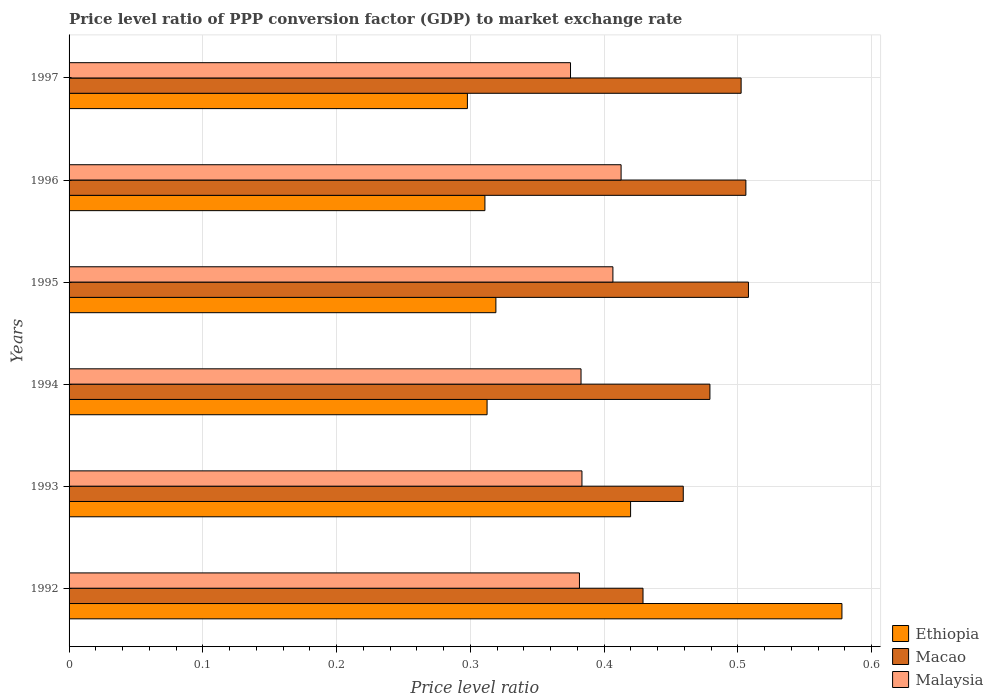How many groups of bars are there?
Your response must be concise. 6. Are the number of bars on each tick of the Y-axis equal?
Your response must be concise. Yes. How many bars are there on the 4th tick from the top?
Offer a very short reply. 3. In how many cases, is the number of bars for a given year not equal to the number of legend labels?
Give a very brief answer. 0. What is the price level ratio in Macao in 1997?
Ensure brevity in your answer.  0.5. Across all years, what is the maximum price level ratio in Macao?
Offer a terse response. 0.51. Across all years, what is the minimum price level ratio in Malaysia?
Provide a short and direct response. 0.37. In which year was the price level ratio in Ethiopia minimum?
Make the answer very short. 1997. What is the total price level ratio in Malaysia in the graph?
Provide a short and direct response. 2.34. What is the difference between the price level ratio in Macao in 1993 and that in 1996?
Provide a short and direct response. -0.05. What is the difference between the price level ratio in Ethiopia in 1992 and the price level ratio in Malaysia in 1997?
Give a very brief answer. 0.2. What is the average price level ratio in Malaysia per year?
Offer a very short reply. 0.39. In the year 1996, what is the difference between the price level ratio in Ethiopia and price level ratio in Malaysia?
Provide a short and direct response. -0.1. In how many years, is the price level ratio in Malaysia greater than 0.12000000000000001 ?
Give a very brief answer. 6. What is the ratio of the price level ratio in Ethiopia in 1996 to that in 1997?
Your answer should be compact. 1.04. Is the difference between the price level ratio in Ethiopia in 1995 and 1996 greater than the difference between the price level ratio in Malaysia in 1995 and 1996?
Your response must be concise. Yes. What is the difference between the highest and the second highest price level ratio in Malaysia?
Your response must be concise. 0.01. What is the difference between the highest and the lowest price level ratio in Macao?
Make the answer very short. 0.08. What does the 2nd bar from the top in 1995 represents?
Your answer should be very brief. Macao. What does the 3rd bar from the bottom in 1997 represents?
Your answer should be compact. Malaysia. Is it the case that in every year, the sum of the price level ratio in Malaysia and price level ratio in Macao is greater than the price level ratio in Ethiopia?
Make the answer very short. Yes. How many bars are there?
Make the answer very short. 18. How many years are there in the graph?
Offer a very short reply. 6. What is the difference between two consecutive major ticks on the X-axis?
Provide a succinct answer. 0.1. Are the values on the major ticks of X-axis written in scientific E-notation?
Keep it short and to the point. No. Does the graph contain any zero values?
Make the answer very short. No. Does the graph contain grids?
Provide a succinct answer. Yes. How are the legend labels stacked?
Your response must be concise. Vertical. What is the title of the graph?
Offer a very short reply. Price level ratio of PPP conversion factor (GDP) to market exchange rate. What is the label or title of the X-axis?
Your answer should be very brief. Price level ratio. What is the Price level ratio of Ethiopia in 1992?
Provide a short and direct response. 0.58. What is the Price level ratio in Macao in 1992?
Your answer should be very brief. 0.43. What is the Price level ratio of Malaysia in 1992?
Your response must be concise. 0.38. What is the Price level ratio in Ethiopia in 1993?
Keep it short and to the point. 0.42. What is the Price level ratio of Macao in 1993?
Ensure brevity in your answer.  0.46. What is the Price level ratio in Malaysia in 1993?
Your response must be concise. 0.38. What is the Price level ratio of Ethiopia in 1994?
Your answer should be compact. 0.31. What is the Price level ratio in Macao in 1994?
Provide a succinct answer. 0.48. What is the Price level ratio of Malaysia in 1994?
Your answer should be compact. 0.38. What is the Price level ratio of Ethiopia in 1995?
Offer a terse response. 0.32. What is the Price level ratio in Macao in 1995?
Provide a succinct answer. 0.51. What is the Price level ratio in Malaysia in 1995?
Your answer should be very brief. 0.41. What is the Price level ratio of Ethiopia in 1996?
Provide a short and direct response. 0.31. What is the Price level ratio of Macao in 1996?
Keep it short and to the point. 0.51. What is the Price level ratio of Malaysia in 1996?
Offer a very short reply. 0.41. What is the Price level ratio of Ethiopia in 1997?
Offer a terse response. 0.3. What is the Price level ratio in Macao in 1997?
Your answer should be very brief. 0.5. What is the Price level ratio of Malaysia in 1997?
Your answer should be very brief. 0.37. Across all years, what is the maximum Price level ratio in Ethiopia?
Make the answer very short. 0.58. Across all years, what is the maximum Price level ratio of Macao?
Ensure brevity in your answer.  0.51. Across all years, what is the maximum Price level ratio of Malaysia?
Your answer should be compact. 0.41. Across all years, what is the minimum Price level ratio in Ethiopia?
Make the answer very short. 0.3. Across all years, what is the minimum Price level ratio in Macao?
Make the answer very short. 0.43. Across all years, what is the minimum Price level ratio in Malaysia?
Provide a succinct answer. 0.37. What is the total Price level ratio of Ethiopia in the graph?
Provide a short and direct response. 2.24. What is the total Price level ratio in Macao in the graph?
Keep it short and to the point. 2.88. What is the total Price level ratio of Malaysia in the graph?
Your answer should be very brief. 2.34. What is the difference between the Price level ratio of Ethiopia in 1992 and that in 1993?
Make the answer very short. 0.16. What is the difference between the Price level ratio of Macao in 1992 and that in 1993?
Provide a succinct answer. -0.03. What is the difference between the Price level ratio of Malaysia in 1992 and that in 1993?
Offer a terse response. -0. What is the difference between the Price level ratio in Ethiopia in 1992 and that in 1994?
Offer a very short reply. 0.27. What is the difference between the Price level ratio of Malaysia in 1992 and that in 1994?
Make the answer very short. -0. What is the difference between the Price level ratio of Ethiopia in 1992 and that in 1995?
Keep it short and to the point. 0.26. What is the difference between the Price level ratio of Macao in 1992 and that in 1995?
Give a very brief answer. -0.08. What is the difference between the Price level ratio in Malaysia in 1992 and that in 1995?
Your response must be concise. -0.03. What is the difference between the Price level ratio of Ethiopia in 1992 and that in 1996?
Provide a short and direct response. 0.27. What is the difference between the Price level ratio in Macao in 1992 and that in 1996?
Your answer should be very brief. -0.08. What is the difference between the Price level ratio in Malaysia in 1992 and that in 1996?
Ensure brevity in your answer.  -0.03. What is the difference between the Price level ratio of Ethiopia in 1992 and that in 1997?
Your response must be concise. 0.28. What is the difference between the Price level ratio of Macao in 1992 and that in 1997?
Provide a succinct answer. -0.07. What is the difference between the Price level ratio of Malaysia in 1992 and that in 1997?
Give a very brief answer. 0.01. What is the difference between the Price level ratio in Ethiopia in 1993 and that in 1994?
Offer a very short reply. 0.11. What is the difference between the Price level ratio of Macao in 1993 and that in 1994?
Your response must be concise. -0.02. What is the difference between the Price level ratio in Malaysia in 1993 and that in 1994?
Provide a succinct answer. 0. What is the difference between the Price level ratio of Ethiopia in 1993 and that in 1995?
Ensure brevity in your answer.  0.1. What is the difference between the Price level ratio in Macao in 1993 and that in 1995?
Your answer should be compact. -0.05. What is the difference between the Price level ratio of Malaysia in 1993 and that in 1995?
Ensure brevity in your answer.  -0.02. What is the difference between the Price level ratio of Ethiopia in 1993 and that in 1996?
Offer a terse response. 0.11. What is the difference between the Price level ratio in Macao in 1993 and that in 1996?
Offer a terse response. -0.05. What is the difference between the Price level ratio in Malaysia in 1993 and that in 1996?
Your answer should be very brief. -0.03. What is the difference between the Price level ratio of Ethiopia in 1993 and that in 1997?
Keep it short and to the point. 0.12. What is the difference between the Price level ratio of Macao in 1993 and that in 1997?
Give a very brief answer. -0.04. What is the difference between the Price level ratio of Malaysia in 1993 and that in 1997?
Provide a short and direct response. 0.01. What is the difference between the Price level ratio of Ethiopia in 1994 and that in 1995?
Ensure brevity in your answer.  -0.01. What is the difference between the Price level ratio of Macao in 1994 and that in 1995?
Provide a short and direct response. -0.03. What is the difference between the Price level ratio in Malaysia in 1994 and that in 1995?
Make the answer very short. -0.02. What is the difference between the Price level ratio of Ethiopia in 1994 and that in 1996?
Offer a terse response. 0. What is the difference between the Price level ratio of Macao in 1994 and that in 1996?
Offer a terse response. -0.03. What is the difference between the Price level ratio in Malaysia in 1994 and that in 1996?
Your response must be concise. -0.03. What is the difference between the Price level ratio of Ethiopia in 1994 and that in 1997?
Provide a short and direct response. 0.01. What is the difference between the Price level ratio in Macao in 1994 and that in 1997?
Provide a succinct answer. -0.02. What is the difference between the Price level ratio in Malaysia in 1994 and that in 1997?
Keep it short and to the point. 0.01. What is the difference between the Price level ratio in Ethiopia in 1995 and that in 1996?
Give a very brief answer. 0.01. What is the difference between the Price level ratio in Macao in 1995 and that in 1996?
Provide a succinct answer. 0. What is the difference between the Price level ratio in Malaysia in 1995 and that in 1996?
Your answer should be very brief. -0.01. What is the difference between the Price level ratio of Ethiopia in 1995 and that in 1997?
Offer a very short reply. 0.02. What is the difference between the Price level ratio in Macao in 1995 and that in 1997?
Your answer should be very brief. 0.01. What is the difference between the Price level ratio of Malaysia in 1995 and that in 1997?
Provide a short and direct response. 0.03. What is the difference between the Price level ratio of Ethiopia in 1996 and that in 1997?
Keep it short and to the point. 0.01. What is the difference between the Price level ratio in Macao in 1996 and that in 1997?
Offer a terse response. 0. What is the difference between the Price level ratio of Malaysia in 1996 and that in 1997?
Keep it short and to the point. 0.04. What is the difference between the Price level ratio in Ethiopia in 1992 and the Price level ratio in Macao in 1993?
Keep it short and to the point. 0.12. What is the difference between the Price level ratio of Ethiopia in 1992 and the Price level ratio of Malaysia in 1993?
Ensure brevity in your answer.  0.19. What is the difference between the Price level ratio of Macao in 1992 and the Price level ratio of Malaysia in 1993?
Provide a short and direct response. 0.05. What is the difference between the Price level ratio of Ethiopia in 1992 and the Price level ratio of Macao in 1994?
Your answer should be compact. 0.1. What is the difference between the Price level ratio of Ethiopia in 1992 and the Price level ratio of Malaysia in 1994?
Your answer should be very brief. 0.2. What is the difference between the Price level ratio in Macao in 1992 and the Price level ratio in Malaysia in 1994?
Make the answer very short. 0.05. What is the difference between the Price level ratio in Ethiopia in 1992 and the Price level ratio in Macao in 1995?
Offer a very short reply. 0.07. What is the difference between the Price level ratio in Ethiopia in 1992 and the Price level ratio in Malaysia in 1995?
Provide a succinct answer. 0.17. What is the difference between the Price level ratio of Macao in 1992 and the Price level ratio of Malaysia in 1995?
Provide a succinct answer. 0.02. What is the difference between the Price level ratio of Ethiopia in 1992 and the Price level ratio of Macao in 1996?
Make the answer very short. 0.07. What is the difference between the Price level ratio in Ethiopia in 1992 and the Price level ratio in Malaysia in 1996?
Keep it short and to the point. 0.17. What is the difference between the Price level ratio of Macao in 1992 and the Price level ratio of Malaysia in 1996?
Offer a very short reply. 0.02. What is the difference between the Price level ratio in Ethiopia in 1992 and the Price level ratio in Macao in 1997?
Offer a very short reply. 0.08. What is the difference between the Price level ratio of Ethiopia in 1992 and the Price level ratio of Malaysia in 1997?
Your answer should be very brief. 0.2. What is the difference between the Price level ratio of Macao in 1992 and the Price level ratio of Malaysia in 1997?
Ensure brevity in your answer.  0.05. What is the difference between the Price level ratio in Ethiopia in 1993 and the Price level ratio in Macao in 1994?
Provide a short and direct response. -0.06. What is the difference between the Price level ratio of Ethiopia in 1993 and the Price level ratio of Malaysia in 1994?
Your answer should be compact. 0.04. What is the difference between the Price level ratio in Macao in 1993 and the Price level ratio in Malaysia in 1994?
Your answer should be very brief. 0.08. What is the difference between the Price level ratio of Ethiopia in 1993 and the Price level ratio of Macao in 1995?
Make the answer very short. -0.09. What is the difference between the Price level ratio in Ethiopia in 1993 and the Price level ratio in Malaysia in 1995?
Your answer should be very brief. 0.01. What is the difference between the Price level ratio in Macao in 1993 and the Price level ratio in Malaysia in 1995?
Your response must be concise. 0.05. What is the difference between the Price level ratio of Ethiopia in 1993 and the Price level ratio of Macao in 1996?
Your response must be concise. -0.09. What is the difference between the Price level ratio in Ethiopia in 1993 and the Price level ratio in Malaysia in 1996?
Provide a succinct answer. 0.01. What is the difference between the Price level ratio of Macao in 1993 and the Price level ratio of Malaysia in 1996?
Give a very brief answer. 0.05. What is the difference between the Price level ratio of Ethiopia in 1993 and the Price level ratio of Macao in 1997?
Make the answer very short. -0.08. What is the difference between the Price level ratio in Ethiopia in 1993 and the Price level ratio in Malaysia in 1997?
Make the answer very short. 0.04. What is the difference between the Price level ratio in Macao in 1993 and the Price level ratio in Malaysia in 1997?
Provide a succinct answer. 0.08. What is the difference between the Price level ratio in Ethiopia in 1994 and the Price level ratio in Macao in 1995?
Offer a very short reply. -0.2. What is the difference between the Price level ratio of Ethiopia in 1994 and the Price level ratio of Malaysia in 1995?
Offer a very short reply. -0.09. What is the difference between the Price level ratio of Macao in 1994 and the Price level ratio of Malaysia in 1995?
Provide a short and direct response. 0.07. What is the difference between the Price level ratio in Ethiopia in 1994 and the Price level ratio in Macao in 1996?
Make the answer very short. -0.19. What is the difference between the Price level ratio of Ethiopia in 1994 and the Price level ratio of Malaysia in 1996?
Give a very brief answer. -0.1. What is the difference between the Price level ratio in Macao in 1994 and the Price level ratio in Malaysia in 1996?
Make the answer very short. 0.07. What is the difference between the Price level ratio in Ethiopia in 1994 and the Price level ratio in Macao in 1997?
Provide a succinct answer. -0.19. What is the difference between the Price level ratio in Ethiopia in 1994 and the Price level ratio in Malaysia in 1997?
Make the answer very short. -0.06. What is the difference between the Price level ratio of Macao in 1994 and the Price level ratio of Malaysia in 1997?
Make the answer very short. 0.1. What is the difference between the Price level ratio of Ethiopia in 1995 and the Price level ratio of Macao in 1996?
Keep it short and to the point. -0.19. What is the difference between the Price level ratio in Ethiopia in 1995 and the Price level ratio in Malaysia in 1996?
Offer a terse response. -0.09. What is the difference between the Price level ratio in Macao in 1995 and the Price level ratio in Malaysia in 1996?
Give a very brief answer. 0.1. What is the difference between the Price level ratio in Ethiopia in 1995 and the Price level ratio in Macao in 1997?
Offer a very short reply. -0.18. What is the difference between the Price level ratio of Ethiopia in 1995 and the Price level ratio of Malaysia in 1997?
Your response must be concise. -0.06. What is the difference between the Price level ratio of Macao in 1995 and the Price level ratio of Malaysia in 1997?
Your response must be concise. 0.13. What is the difference between the Price level ratio in Ethiopia in 1996 and the Price level ratio in Macao in 1997?
Keep it short and to the point. -0.19. What is the difference between the Price level ratio of Ethiopia in 1996 and the Price level ratio of Malaysia in 1997?
Your answer should be compact. -0.06. What is the difference between the Price level ratio in Macao in 1996 and the Price level ratio in Malaysia in 1997?
Ensure brevity in your answer.  0.13. What is the average Price level ratio of Ethiopia per year?
Offer a terse response. 0.37. What is the average Price level ratio of Macao per year?
Provide a succinct answer. 0.48. What is the average Price level ratio in Malaysia per year?
Make the answer very short. 0.39. In the year 1992, what is the difference between the Price level ratio in Ethiopia and Price level ratio in Macao?
Give a very brief answer. 0.15. In the year 1992, what is the difference between the Price level ratio in Ethiopia and Price level ratio in Malaysia?
Provide a short and direct response. 0.2. In the year 1992, what is the difference between the Price level ratio in Macao and Price level ratio in Malaysia?
Keep it short and to the point. 0.05. In the year 1993, what is the difference between the Price level ratio of Ethiopia and Price level ratio of Macao?
Offer a very short reply. -0.04. In the year 1993, what is the difference between the Price level ratio in Ethiopia and Price level ratio in Malaysia?
Keep it short and to the point. 0.04. In the year 1993, what is the difference between the Price level ratio in Macao and Price level ratio in Malaysia?
Keep it short and to the point. 0.08. In the year 1994, what is the difference between the Price level ratio of Ethiopia and Price level ratio of Macao?
Your response must be concise. -0.17. In the year 1994, what is the difference between the Price level ratio of Ethiopia and Price level ratio of Malaysia?
Your answer should be compact. -0.07. In the year 1994, what is the difference between the Price level ratio of Macao and Price level ratio of Malaysia?
Keep it short and to the point. 0.1. In the year 1995, what is the difference between the Price level ratio in Ethiopia and Price level ratio in Macao?
Give a very brief answer. -0.19. In the year 1995, what is the difference between the Price level ratio in Ethiopia and Price level ratio in Malaysia?
Offer a terse response. -0.09. In the year 1995, what is the difference between the Price level ratio in Macao and Price level ratio in Malaysia?
Offer a terse response. 0.1. In the year 1996, what is the difference between the Price level ratio in Ethiopia and Price level ratio in Macao?
Your answer should be compact. -0.2. In the year 1996, what is the difference between the Price level ratio in Ethiopia and Price level ratio in Malaysia?
Your response must be concise. -0.1. In the year 1996, what is the difference between the Price level ratio in Macao and Price level ratio in Malaysia?
Provide a short and direct response. 0.09. In the year 1997, what is the difference between the Price level ratio in Ethiopia and Price level ratio in Macao?
Provide a short and direct response. -0.2. In the year 1997, what is the difference between the Price level ratio in Ethiopia and Price level ratio in Malaysia?
Give a very brief answer. -0.08. In the year 1997, what is the difference between the Price level ratio of Macao and Price level ratio of Malaysia?
Provide a succinct answer. 0.13. What is the ratio of the Price level ratio in Ethiopia in 1992 to that in 1993?
Your response must be concise. 1.38. What is the ratio of the Price level ratio in Macao in 1992 to that in 1993?
Give a very brief answer. 0.93. What is the ratio of the Price level ratio of Ethiopia in 1992 to that in 1994?
Make the answer very short. 1.85. What is the ratio of the Price level ratio of Macao in 1992 to that in 1994?
Offer a very short reply. 0.9. What is the ratio of the Price level ratio of Malaysia in 1992 to that in 1994?
Your answer should be very brief. 1. What is the ratio of the Price level ratio in Ethiopia in 1992 to that in 1995?
Offer a terse response. 1.81. What is the ratio of the Price level ratio in Macao in 1992 to that in 1995?
Your answer should be compact. 0.84. What is the ratio of the Price level ratio in Malaysia in 1992 to that in 1995?
Ensure brevity in your answer.  0.94. What is the ratio of the Price level ratio of Ethiopia in 1992 to that in 1996?
Give a very brief answer. 1.86. What is the ratio of the Price level ratio in Macao in 1992 to that in 1996?
Offer a very short reply. 0.85. What is the ratio of the Price level ratio in Malaysia in 1992 to that in 1996?
Provide a succinct answer. 0.92. What is the ratio of the Price level ratio of Ethiopia in 1992 to that in 1997?
Your answer should be very brief. 1.94. What is the ratio of the Price level ratio of Macao in 1992 to that in 1997?
Provide a succinct answer. 0.85. What is the ratio of the Price level ratio in Malaysia in 1992 to that in 1997?
Make the answer very short. 1.02. What is the ratio of the Price level ratio of Ethiopia in 1993 to that in 1994?
Offer a very short reply. 1.34. What is the ratio of the Price level ratio of Macao in 1993 to that in 1994?
Offer a terse response. 0.96. What is the ratio of the Price level ratio of Malaysia in 1993 to that in 1994?
Offer a very short reply. 1. What is the ratio of the Price level ratio in Ethiopia in 1993 to that in 1995?
Keep it short and to the point. 1.32. What is the ratio of the Price level ratio in Macao in 1993 to that in 1995?
Your answer should be very brief. 0.9. What is the ratio of the Price level ratio of Malaysia in 1993 to that in 1995?
Your response must be concise. 0.94. What is the ratio of the Price level ratio in Ethiopia in 1993 to that in 1996?
Offer a terse response. 1.35. What is the ratio of the Price level ratio of Macao in 1993 to that in 1996?
Keep it short and to the point. 0.91. What is the ratio of the Price level ratio of Malaysia in 1993 to that in 1996?
Offer a very short reply. 0.93. What is the ratio of the Price level ratio in Ethiopia in 1993 to that in 1997?
Keep it short and to the point. 1.41. What is the ratio of the Price level ratio in Macao in 1993 to that in 1997?
Keep it short and to the point. 0.91. What is the ratio of the Price level ratio of Malaysia in 1993 to that in 1997?
Provide a succinct answer. 1.02. What is the ratio of the Price level ratio in Ethiopia in 1994 to that in 1995?
Your response must be concise. 0.98. What is the ratio of the Price level ratio of Macao in 1994 to that in 1995?
Ensure brevity in your answer.  0.94. What is the ratio of the Price level ratio in Malaysia in 1994 to that in 1995?
Ensure brevity in your answer.  0.94. What is the ratio of the Price level ratio of Ethiopia in 1994 to that in 1996?
Give a very brief answer. 1.01. What is the ratio of the Price level ratio of Macao in 1994 to that in 1996?
Provide a succinct answer. 0.95. What is the ratio of the Price level ratio in Malaysia in 1994 to that in 1996?
Provide a succinct answer. 0.93. What is the ratio of the Price level ratio of Ethiopia in 1994 to that in 1997?
Make the answer very short. 1.05. What is the ratio of the Price level ratio in Macao in 1994 to that in 1997?
Make the answer very short. 0.95. What is the ratio of the Price level ratio of Malaysia in 1994 to that in 1997?
Provide a succinct answer. 1.02. What is the ratio of the Price level ratio of Ethiopia in 1995 to that in 1996?
Ensure brevity in your answer.  1.03. What is the ratio of the Price level ratio of Malaysia in 1995 to that in 1996?
Give a very brief answer. 0.99. What is the ratio of the Price level ratio in Ethiopia in 1995 to that in 1997?
Make the answer very short. 1.07. What is the ratio of the Price level ratio of Macao in 1995 to that in 1997?
Provide a short and direct response. 1.01. What is the ratio of the Price level ratio of Malaysia in 1995 to that in 1997?
Keep it short and to the point. 1.08. What is the ratio of the Price level ratio of Ethiopia in 1996 to that in 1997?
Make the answer very short. 1.04. What is the ratio of the Price level ratio of Macao in 1996 to that in 1997?
Your answer should be compact. 1.01. What is the ratio of the Price level ratio in Malaysia in 1996 to that in 1997?
Give a very brief answer. 1.1. What is the difference between the highest and the second highest Price level ratio in Ethiopia?
Your answer should be compact. 0.16. What is the difference between the highest and the second highest Price level ratio in Macao?
Offer a very short reply. 0. What is the difference between the highest and the second highest Price level ratio in Malaysia?
Provide a succinct answer. 0.01. What is the difference between the highest and the lowest Price level ratio in Ethiopia?
Provide a short and direct response. 0.28. What is the difference between the highest and the lowest Price level ratio in Macao?
Offer a very short reply. 0.08. What is the difference between the highest and the lowest Price level ratio of Malaysia?
Give a very brief answer. 0.04. 